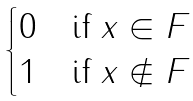Convert formula to latex. <formula><loc_0><loc_0><loc_500><loc_500>\begin{cases} 0 & \text {if $x\in F$} \\ 1 & \text {if $x\notin F$} \end{cases}</formula> 